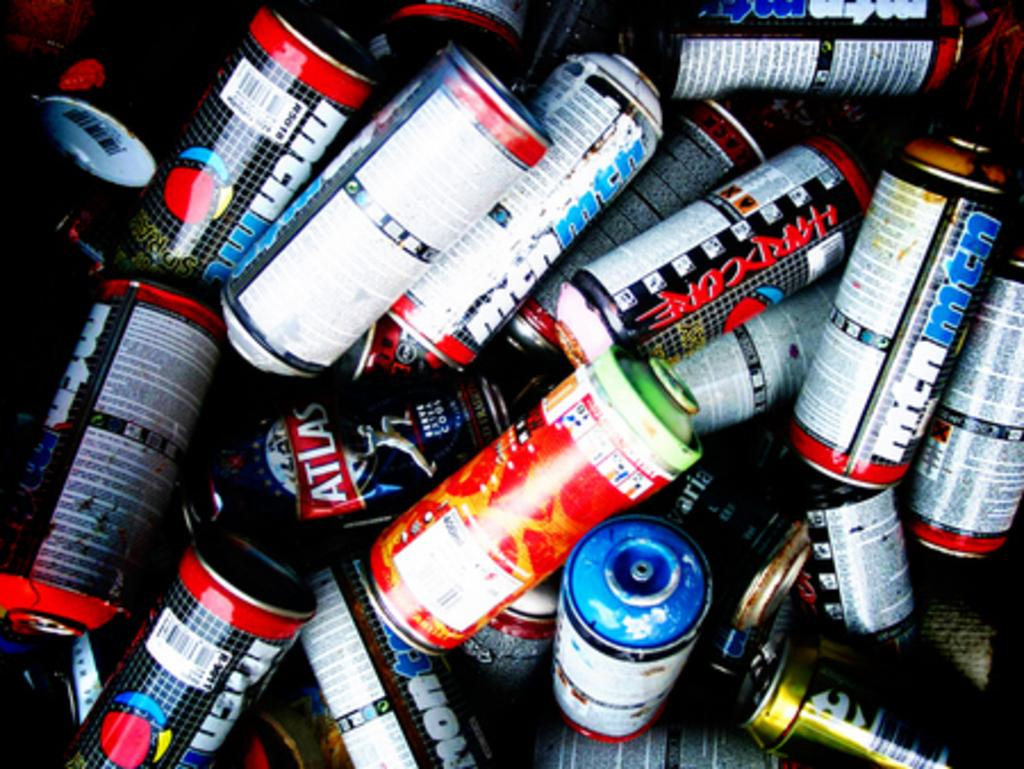Provide a one-sentence caption for the provided image. Many cans including one with the word HARDCORE down its side are in a pile. 